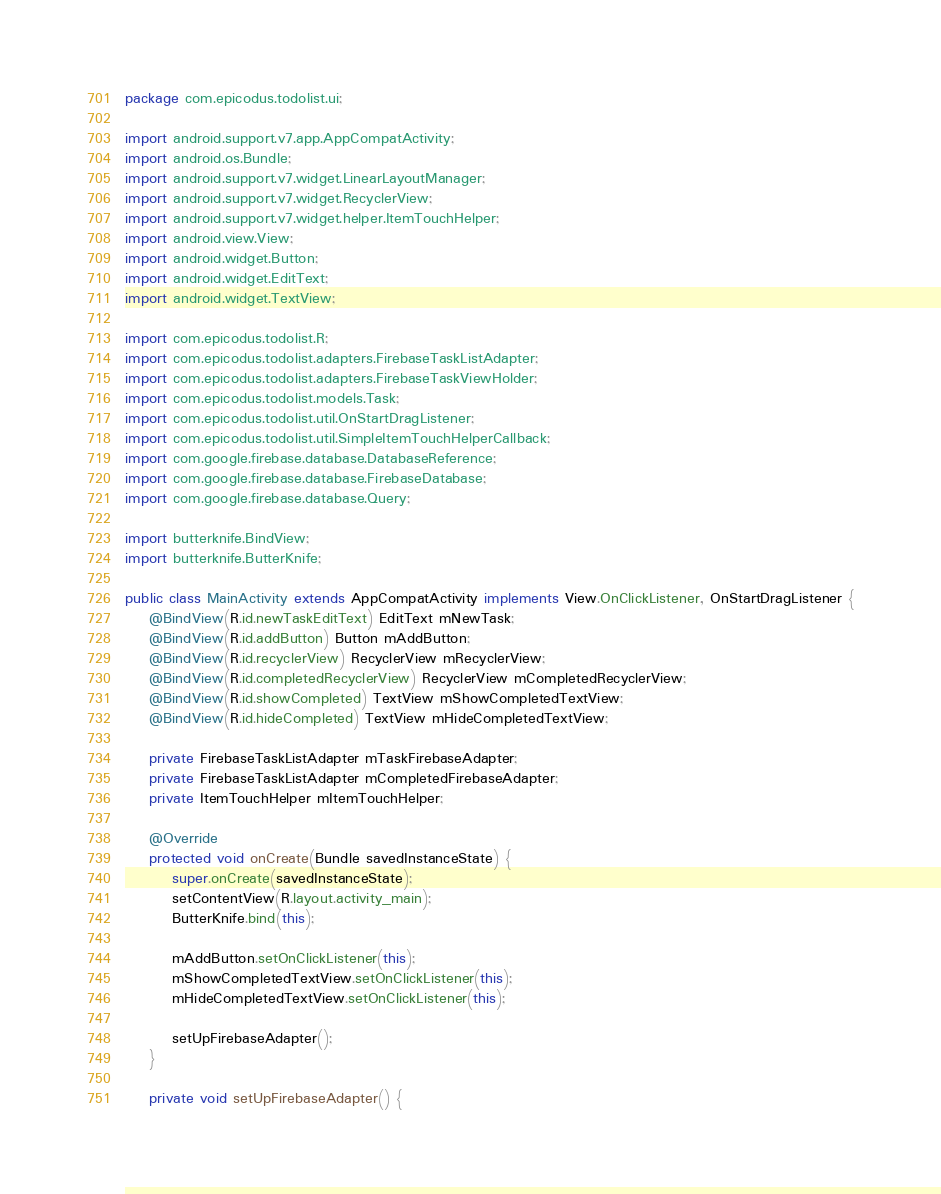Convert code to text. <code><loc_0><loc_0><loc_500><loc_500><_Java_>package com.epicodus.todolist.ui;

import android.support.v7.app.AppCompatActivity;
import android.os.Bundle;
import android.support.v7.widget.LinearLayoutManager;
import android.support.v7.widget.RecyclerView;
import android.support.v7.widget.helper.ItemTouchHelper;
import android.view.View;
import android.widget.Button;
import android.widget.EditText;
import android.widget.TextView;

import com.epicodus.todolist.R;
import com.epicodus.todolist.adapters.FirebaseTaskListAdapter;
import com.epicodus.todolist.adapters.FirebaseTaskViewHolder;
import com.epicodus.todolist.models.Task;
import com.epicodus.todolist.util.OnStartDragListener;
import com.epicodus.todolist.util.SimpleItemTouchHelperCallback;
import com.google.firebase.database.DatabaseReference;
import com.google.firebase.database.FirebaseDatabase;
import com.google.firebase.database.Query;

import butterknife.BindView;
import butterknife.ButterKnife;

public class MainActivity extends AppCompatActivity implements View.OnClickListener, OnStartDragListener {
    @BindView(R.id.newTaskEditText) EditText mNewTask;
    @BindView(R.id.addButton) Button mAddButton;
    @BindView(R.id.recyclerView) RecyclerView mRecyclerView;
    @BindView(R.id.completedRecyclerView) RecyclerView mCompletedRecyclerView;
    @BindView(R.id.showCompleted) TextView mShowCompletedTextView;
    @BindView(R.id.hideCompleted) TextView mHideCompletedTextView;

    private FirebaseTaskListAdapter mTaskFirebaseAdapter;
    private FirebaseTaskListAdapter mCompletedFirebaseAdapter;
    private ItemTouchHelper mItemTouchHelper;

    @Override
    protected void onCreate(Bundle savedInstanceState) {
        super.onCreate(savedInstanceState);
        setContentView(R.layout.activity_main);
        ButterKnife.bind(this);

        mAddButton.setOnClickListener(this);
        mShowCompletedTextView.setOnClickListener(this);
        mHideCompletedTextView.setOnClickListener(this);

        setUpFirebaseAdapter();
    }

    private void setUpFirebaseAdapter() {</code> 